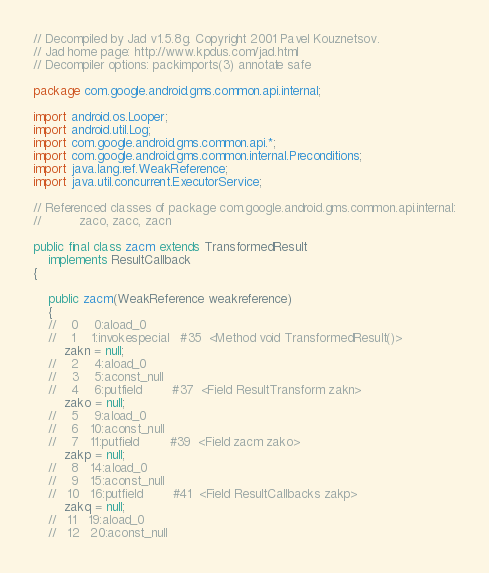<code> <loc_0><loc_0><loc_500><loc_500><_Java_>// Decompiled by Jad v1.5.8g. Copyright 2001 Pavel Kouznetsov.
// Jad home page: http://www.kpdus.com/jad.html
// Decompiler options: packimports(3) annotate safe 

package com.google.android.gms.common.api.internal;

import android.os.Looper;
import android.util.Log;
import com.google.android.gms.common.api.*;
import com.google.android.gms.common.internal.Preconditions;
import java.lang.ref.WeakReference;
import java.util.concurrent.ExecutorService;

// Referenced classes of package com.google.android.gms.common.api.internal:
//			zaco, zacc, zacn

public final class zacm extends TransformedResult
	implements ResultCallback
{

	public zacm(WeakReference weakreference)
	{
	//    0    0:aload_0         
	//    1    1:invokespecial   #35  <Method void TransformedResult()>
		zakn = null;
	//    2    4:aload_0         
	//    3    5:aconst_null     
	//    4    6:putfield        #37  <Field ResultTransform zakn>
		zako = null;
	//    5    9:aload_0         
	//    6   10:aconst_null     
	//    7   11:putfield        #39  <Field zacm zako>
		zakp = null;
	//    8   14:aload_0         
	//    9   15:aconst_null     
	//   10   16:putfield        #41  <Field ResultCallbacks zakp>
		zakq = null;
	//   11   19:aload_0         
	//   12   20:aconst_null     </code> 